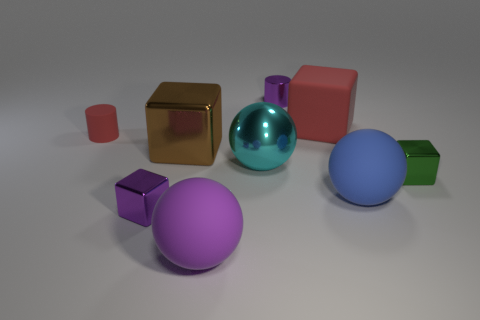Add 1 tiny brown rubber cylinders. How many objects exist? 10 Subtract all metallic cubes. How many cubes are left? 1 Subtract all balls. How many objects are left? 6 Subtract 2 cylinders. How many cylinders are left? 0 Subtract all purple cylinders. How many cylinders are left? 1 Subtract 1 blue balls. How many objects are left? 8 Subtract all purple cubes. Subtract all brown balls. How many cubes are left? 3 Subtract all gray balls. How many green blocks are left? 1 Subtract all large brown objects. Subtract all big cyan metal objects. How many objects are left? 7 Add 4 blue balls. How many blue balls are left? 5 